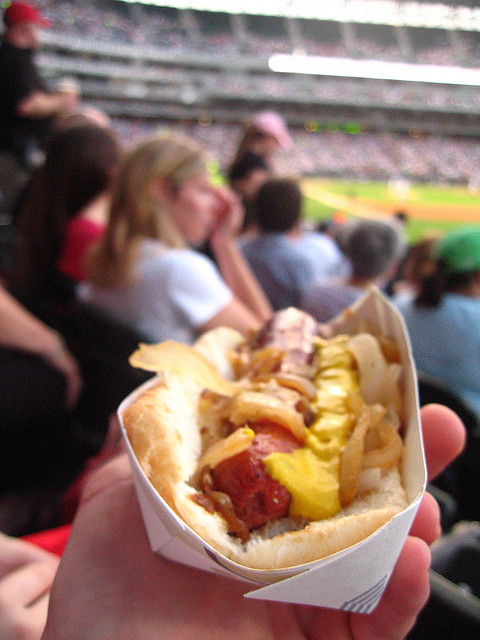<image>Has part of the hot dog been eaten? There is no information that part of the hot dog has been eaten. Has part of the hot dog been eaten? No, it is not clear if part of the hot dog has been eaten. 